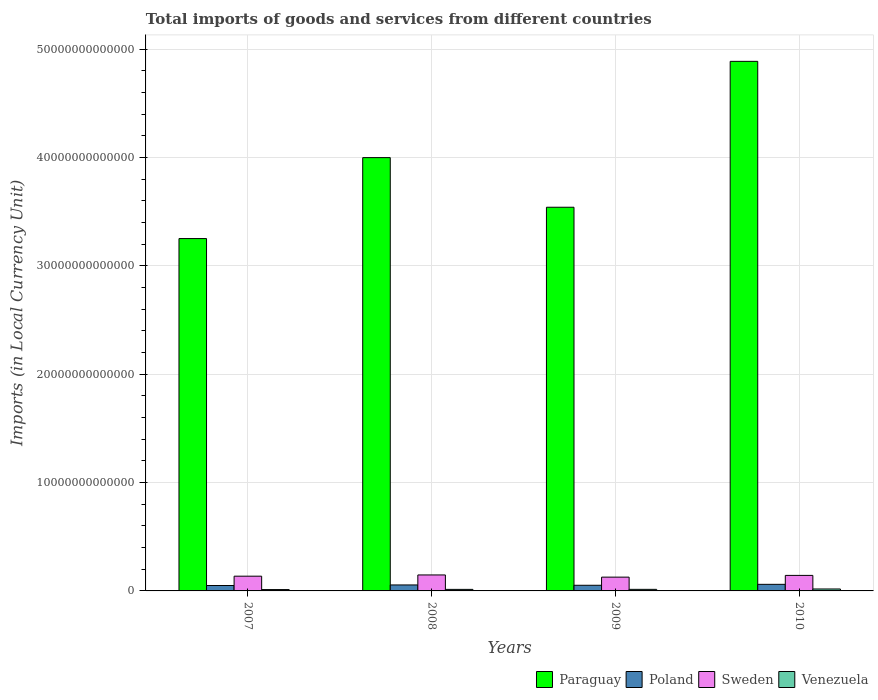How many different coloured bars are there?
Your answer should be compact. 4. Are the number of bars on each tick of the X-axis equal?
Make the answer very short. Yes. How many bars are there on the 1st tick from the right?
Ensure brevity in your answer.  4. What is the label of the 1st group of bars from the left?
Your response must be concise. 2007. In how many cases, is the number of bars for a given year not equal to the number of legend labels?
Give a very brief answer. 0. What is the Amount of goods and services imports in Venezuela in 2007?
Offer a very short reply. 1.24e+11. Across all years, what is the maximum Amount of goods and services imports in Sweden?
Offer a very short reply. 1.48e+12. Across all years, what is the minimum Amount of goods and services imports in Poland?
Make the answer very short. 5.00e+11. What is the total Amount of goods and services imports in Poland in the graph?
Offer a terse response. 2.18e+12. What is the difference between the Amount of goods and services imports in Paraguay in 2007 and that in 2010?
Provide a succinct answer. -1.64e+13. What is the difference between the Amount of goods and services imports in Poland in 2008 and the Amount of goods and services imports in Venezuela in 2010?
Provide a short and direct response. 3.73e+11. What is the average Amount of goods and services imports in Sweden per year?
Ensure brevity in your answer.  1.39e+12. In the year 2008, what is the difference between the Amount of goods and services imports in Venezuela and Amount of goods and services imports in Sweden?
Give a very brief answer. -1.33e+12. What is the ratio of the Amount of goods and services imports in Poland in 2007 to that in 2009?
Provide a short and direct response. 0.96. Is the Amount of goods and services imports in Venezuela in 2007 less than that in 2010?
Make the answer very short. Yes. Is the difference between the Amount of goods and services imports in Venezuela in 2007 and 2009 greater than the difference between the Amount of goods and services imports in Sweden in 2007 and 2009?
Offer a terse response. No. What is the difference between the highest and the second highest Amount of goods and services imports in Poland?
Offer a terse response. 5.61e+1. What is the difference between the highest and the lowest Amount of goods and services imports in Poland?
Keep it short and to the point. 1.08e+11. In how many years, is the Amount of goods and services imports in Venezuela greater than the average Amount of goods and services imports in Venezuela taken over all years?
Provide a succinct answer. 1. Is it the case that in every year, the sum of the Amount of goods and services imports in Venezuela and Amount of goods and services imports in Paraguay is greater than the sum of Amount of goods and services imports in Sweden and Amount of goods and services imports in Poland?
Your answer should be compact. Yes. What does the 1st bar from the left in 2007 represents?
Offer a terse response. Paraguay. How many bars are there?
Your response must be concise. 16. Are all the bars in the graph horizontal?
Your response must be concise. No. How many years are there in the graph?
Your answer should be compact. 4. What is the difference between two consecutive major ticks on the Y-axis?
Provide a short and direct response. 1.00e+13. Are the values on the major ticks of Y-axis written in scientific E-notation?
Your answer should be compact. No. Does the graph contain grids?
Provide a succinct answer. Yes. What is the title of the graph?
Keep it short and to the point. Total imports of goods and services from different countries. What is the label or title of the X-axis?
Offer a very short reply. Years. What is the label or title of the Y-axis?
Your answer should be very brief. Imports (in Local Currency Unit). What is the Imports (in Local Currency Unit) of Paraguay in 2007?
Ensure brevity in your answer.  3.25e+13. What is the Imports (in Local Currency Unit) in Poland in 2007?
Offer a very short reply. 5.00e+11. What is the Imports (in Local Currency Unit) of Sweden in 2007?
Offer a very short reply. 1.36e+12. What is the Imports (in Local Currency Unit) of Venezuela in 2007?
Your response must be concise. 1.24e+11. What is the Imports (in Local Currency Unit) of Paraguay in 2008?
Give a very brief answer. 4.00e+13. What is the Imports (in Local Currency Unit) in Poland in 2008?
Provide a short and direct response. 5.52e+11. What is the Imports (in Local Currency Unit) of Sweden in 2008?
Provide a short and direct response. 1.48e+12. What is the Imports (in Local Currency Unit) of Venezuela in 2008?
Offer a very short reply. 1.42e+11. What is the Imports (in Local Currency Unit) of Paraguay in 2009?
Ensure brevity in your answer.  3.54e+13. What is the Imports (in Local Currency Unit) in Poland in 2009?
Provide a short and direct response. 5.22e+11. What is the Imports (in Local Currency Unit) of Sweden in 2009?
Offer a terse response. 1.27e+12. What is the Imports (in Local Currency Unit) of Venezuela in 2009?
Provide a short and direct response. 1.45e+11. What is the Imports (in Local Currency Unit) in Paraguay in 2010?
Give a very brief answer. 4.89e+13. What is the Imports (in Local Currency Unit) in Poland in 2010?
Offer a very short reply. 6.08e+11. What is the Imports (in Local Currency Unit) of Sweden in 2010?
Provide a short and direct response. 1.43e+12. What is the Imports (in Local Currency Unit) of Venezuela in 2010?
Your answer should be very brief. 1.79e+11. Across all years, what is the maximum Imports (in Local Currency Unit) of Paraguay?
Ensure brevity in your answer.  4.89e+13. Across all years, what is the maximum Imports (in Local Currency Unit) in Poland?
Offer a terse response. 6.08e+11. Across all years, what is the maximum Imports (in Local Currency Unit) of Sweden?
Keep it short and to the point. 1.48e+12. Across all years, what is the maximum Imports (in Local Currency Unit) of Venezuela?
Offer a very short reply. 1.79e+11. Across all years, what is the minimum Imports (in Local Currency Unit) in Paraguay?
Offer a very short reply. 3.25e+13. Across all years, what is the minimum Imports (in Local Currency Unit) in Poland?
Offer a very short reply. 5.00e+11. Across all years, what is the minimum Imports (in Local Currency Unit) in Sweden?
Keep it short and to the point. 1.27e+12. Across all years, what is the minimum Imports (in Local Currency Unit) of Venezuela?
Give a very brief answer. 1.24e+11. What is the total Imports (in Local Currency Unit) of Paraguay in the graph?
Offer a very short reply. 1.57e+14. What is the total Imports (in Local Currency Unit) in Poland in the graph?
Ensure brevity in your answer.  2.18e+12. What is the total Imports (in Local Currency Unit) in Sweden in the graph?
Your answer should be compact. 5.54e+12. What is the total Imports (in Local Currency Unit) in Venezuela in the graph?
Your answer should be very brief. 5.90e+11. What is the difference between the Imports (in Local Currency Unit) of Paraguay in 2007 and that in 2008?
Your response must be concise. -7.47e+12. What is the difference between the Imports (in Local Currency Unit) in Poland in 2007 and that in 2008?
Make the answer very short. -5.17e+1. What is the difference between the Imports (in Local Currency Unit) in Sweden in 2007 and that in 2008?
Make the answer very short. -1.14e+11. What is the difference between the Imports (in Local Currency Unit) of Venezuela in 2007 and that in 2008?
Offer a very short reply. -1.84e+1. What is the difference between the Imports (in Local Currency Unit) in Paraguay in 2007 and that in 2009?
Make the answer very short. -2.89e+12. What is the difference between the Imports (in Local Currency Unit) of Poland in 2007 and that in 2009?
Provide a short and direct response. -2.21e+1. What is the difference between the Imports (in Local Currency Unit) of Sweden in 2007 and that in 2009?
Give a very brief answer. 8.87e+1. What is the difference between the Imports (in Local Currency Unit) in Venezuela in 2007 and that in 2009?
Provide a short and direct response. -2.06e+1. What is the difference between the Imports (in Local Currency Unit) in Paraguay in 2007 and that in 2010?
Your response must be concise. -1.64e+13. What is the difference between the Imports (in Local Currency Unit) in Poland in 2007 and that in 2010?
Your answer should be compact. -1.08e+11. What is the difference between the Imports (in Local Currency Unit) of Sweden in 2007 and that in 2010?
Give a very brief answer. -7.22e+1. What is the difference between the Imports (in Local Currency Unit) of Venezuela in 2007 and that in 2010?
Your answer should be compact. -5.50e+1. What is the difference between the Imports (in Local Currency Unit) of Paraguay in 2008 and that in 2009?
Provide a succinct answer. 4.58e+12. What is the difference between the Imports (in Local Currency Unit) in Poland in 2008 and that in 2009?
Offer a very short reply. 2.97e+1. What is the difference between the Imports (in Local Currency Unit) of Sweden in 2008 and that in 2009?
Provide a short and direct response. 2.03e+11. What is the difference between the Imports (in Local Currency Unit) in Venezuela in 2008 and that in 2009?
Ensure brevity in your answer.  -2.29e+09. What is the difference between the Imports (in Local Currency Unit) in Paraguay in 2008 and that in 2010?
Ensure brevity in your answer.  -8.89e+12. What is the difference between the Imports (in Local Currency Unit) of Poland in 2008 and that in 2010?
Make the answer very short. -5.61e+1. What is the difference between the Imports (in Local Currency Unit) of Sweden in 2008 and that in 2010?
Your answer should be compact. 4.19e+1. What is the difference between the Imports (in Local Currency Unit) of Venezuela in 2008 and that in 2010?
Offer a terse response. -3.67e+1. What is the difference between the Imports (in Local Currency Unit) in Paraguay in 2009 and that in 2010?
Provide a succinct answer. -1.35e+13. What is the difference between the Imports (in Local Currency Unit) of Poland in 2009 and that in 2010?
Ensure brevity in your answer.  -8.58e+1. What is the difference between the Imports (in Local Currency Unit) of Sweden in 2009 and that in 2010?
Offer a very short reply. -1.61e+11. What is the difference between the Imports (in Local Currency Unit) of Venezuela in 2009 and that in 2010?
Your answer should be compact. -3.44e+1. What is the difference between the Imports (in Local Currency Unit) in Paraguay in 2007 and the Imports (in Local Currency Unit) in Poland in 2008?
Give a very brief answer. 3.20e+13. What is the difference between the Imports (in Local Currency Unit) in Paraguay in 2007 and the Imports (in Local Currency Unit) in Sweden in 2008?
Offer a very short reply. 3.10e+13. What is the difference between the Imports (in Local Currency Unit) in Paraguay in 2007 and the Imports (in Local Currency Unit) in Venezuela in 2008?
Make the answer very short. 3.24e+13. What is the difference between the Imports (in Local Currency Unit) in Poland in 2007 and the Imports (in Local Currency Unit) in Sweden in 2008?
Ensure brevity in your answer.  -9.75e+11. What is the difference between the Imports (in Local Currency Unit) of Poland in 2007 and the Imports (in Local Currency Unit) of Venezuela in 2008?
Offer a terse response. 3.58e+11. What is the difference between the Imports (in Local Currency Unit) in Sweden in 2007 and the Imports (in Local Currency Unit) in Venezuela in 2008?
Offer a very short reply. 1.22e+12. What is the difference between the Imports (in Local Currency Unit) in Paraguay in 2007 and the Imports (in Local Currency Unit) in Poland in 2009?
Give a very brief answer. 3.20e+13. What is the difference between the Imports (in Local Currency Unit) of Paraguay in 2007 and the Imports (in Local Currency Unit) of Sweden in 2009?
Keep it short and to the point. 3.12e+13. What is the difference between the Imports (in Local Currency Unit) in Paraguay in 2007 and the Imports (in Local Currency Unit) in Venezuela in 2009?
Offer a very short reply. 3.24e+13. What is the difference between the Imports (in Local Currency Unit) of Poland in 2007 and the Imports (in Local Currency Unit) of Sweden in 2009?
Ensure brevity in your answer.  -7.72e+11. What is the difference between the Imports (in Local Currency Unit) in Poland in 2007 and the Imports (in Local Currency Unit) in Venezuela in 2009?
Offer a very short reply. 3.55e+11. What is the difference between the Imports (in Local Currency Unit) in Sweden in 2007 and the Imports (in Local Currency Unit) in Venezuela in 2009?
Offer a very short reply. 1.22e+12. What is the difference between the Imports (in Local Currency Unit) in Paraguay in 2007 and the Imports (in Local Currency Unit) in Poland in 2010?
Keep it short and to the point. 3.19e+13. What is the difference between the Imports (in Local Currency Unit) in Paraguay in 2007 and the Imports (in Local Currency Unit) in Sweden in 2010?
Make the answer very short. 3.11e+13. What is the difference between the Imports (in Local Currency Unit) in Paraguay in 2007 and the Imports (in Local Currency Unit) in Venezuela in 2010?
Offer a terse response. 3.23e+13. What is the difference between the Imports (in Local Currency Unit) in Poland in 2007 and the Imports (in Local Currency Unit) in Sweden in 2010?
Your answer should be very brief. -9.33e+11. What is the difference between the Imports (in Local Currency Unit) of Poland in 2007 and the Imports (in Local Currency Unit) of Venezuela in 2010?
Your answer should be very brief. 3.21e+11. What is the difference between the Imports (in Local Currency Unit) in Sweden in 2007 and the Imports (in Local Currency Unit) in Venezuela in 2010?
Ensure brevity in your answer.  1.18e+12. What is the difference between the Imports (in Local Currency Unit) in Paraguay in 2008 and the Imports (in Local Currency Unit) in Poland in 2009?
Keep it short and to the point. 3.95e+13. What is the difference between the Imports (in Local Currency Unit) in Paraguay in 2008 and the Imports (in Local Currency Unit) in Sweden in 2009?
Provide a succinct answer. 3.87e+13. What is the difference between the Imports (in Local Currency Unit) in Paraguay in 2008 and the Imports (in Local Currency Unit) in Venezuela in 2009?
Offer a terse response. 3.98e+13. What is the difference between the Imports (in Local Currency Unit) in Poland in 2008 and the Imports (in Local Currency Unit) in Sweden in 2009?
Ensure brevity in your answer.  -7.21e+11. What is the difference between the Imports (in Local Currency Unit) of Poland in 2008 and the Imports (in Local Currency Unit) of Venezuela in 2009?
Provide a succinct answer. 4.07e+11. What is the difference between the Imports (in Local Currency Unit) in Sweden in 2008 and the Imports (in Local Currency Unit) in Venezuela in 2009?
Offer a terse response. 1.33e+12. What is the difference between the Imports (in Local Currency Unit) of Paraguay in 2008 and the Imports (in Local Currency Unit) of Poland in 2010?
Give a very brief answer. 3.94e+13. What is the difference between the Imports (in Local Currency Unit) of Paraguay in 2008 and the Imports (in Local Currency Unit) of Sweden in 2010?
Keep it short and to the point. 3.86e+13. What is the difference between the Imports (in Local Currency Unit) of Paraguay in 2008 and the Imports (in Local Currency Unit) of Venezuela in 2010?
Your response must be concise. 3.98e+13. What is the difference between the Imports (in Local Currency Unit) of Poland in 2008 and the Imports (in Local Currency Unit) of Sweden in 2010?
Keep it short and to the point. -8.82e+11. What is the difference between the Imports (in Local Currency Unit) in Poland in 2008 and the Imports (in Local Currency Unit) in Venezuela in 2010?
Make the answer very short. 3.73e+11. What is the difference between the Imports (in Local Currency Unit) in Sweden in 2008 and the Imports (in Local Currency Unit) in Venezuela in 2010?
Offer a very short reply. 1.30e+12. What is the difference between the Imports (in Local Currency Unit) of Paraguay in 2009 and the Imports (in Local Currency Unit) of Poland in 2010?
Your answer should be very brief. 3.48e+13. What is the difference between the Imports (in Local Currency Unit) in Paraguay in 2009 and the Imports (in Local Currency Unit) in Sweden in 2010?
Provide a short and direct response. 3.40e+13. What is the difference between the Imports (in Local Currency Unit) in Paraguay in 2009 and the Imports (in Local Currency Unit) in Venezuela in 2010?
Provide a succinct answer. 3.52e+13. What is the difference between the Imports (in Local Currency Unit) of Poland in 2009 and the Imports (in Local Currency Unit) of Sweden in 2010?
Provide a short and direct response. -9.11e+11. What is the difference between the Imports (in Local Currency Unit) of Poland in 2009 and the Imports (in Local Currency Unit) of Venezuela in 2010?
Your answer should be very brief. 3.43e+11. What is the difference between the Imports (in Local Currency Unit) of Sweden in 2009 and the Imports (in Local Currency Unit) of Venezuela in 2010?
Your answer should be compact. 1.09e+12. What is the average Imports (in Local Currency Unit) of Paraguay per year?
Your response must be concise. 3.92e+13. What is the average Imports (in Local Currency Unit) of Poland per year?
Offer a very short reply. 5.45e+11. What is the average Imports (in Local Currency Unit) of Sweden per year?
Give a very brief answer. 1.39e+12. What is the average Imports (in Local Currency Unit) of Venezuela per year?
Provide a succinct answer. 1.47e+11. In the year 2007, what is the difference between the Imports (in Local Currency Unit) of Paraguay and Imports (in Local Currency Unit) of Poland?
Your answer should be very brief. 3.20e+13. In the year 2007, what is the difference between the Imports (in Local Currency Unit) in Paraguay and Imports (in Local Currency Unit) in Sweden?
Offer a very short reply. 3.12e+13. In the year 2007, what is the difference between the Imports (in Local Currency Unit) in Paraguay and Imports (in Local Currency Unit) in Venezuela?
Offer a very short reply. 3.24e+13. In the year 2007, what is the difference between the Imports (in Local Currency Unit) in Poland and Imports (in Local Currency Unit) in Sweden?
Ensure brevity in your answer.  -8.61e+11. In the year 2007, what is the difference between the Imports (in Local Currency Unit) in Poland and Imports (in Local Currency Unit) in Venezuela?
Your answer should be very brief. 3.76e+11. In the year 2007, what is the difference between the Imports (in Local Currency Unit) of Sweden and Imports (in Local Currency Unit) of Venezuela?
Your answer should be very brief. 1.24e+12. In the year 2008, what is the difference between the Imports (in Local Currency Unit) in Paraguay and Imports (in Local Currency Unit) in Poland?
Your answer should be compact. 3.94e+13. In the year 2008, what is the difference between the Imports (in Local Currency Unit) of Paraguay and Imports (in Local Currency Unit) of Sweden?
Your response must be concise. 3.85e+13. In the year 2008, what is the difference between the Imports (in Local Currency Unit) of Paraguay and Imports (in Local Currency Unit) of Venezuela?
Ensure brevity in your answer.  3.99e+13. In the year 2008, what is the difference between the Imports (in Local Currency Unit) in Poland and Imports (in Local Currency Unit) in Sweden?
Offer a very short reply. -9.23e+11. In the year 2008, what is the difference between the Imports (in Local Currency Unit) in Poland and Imports (in Local Currency Unit) in Venezuela?
Give a very brief answer. 4.09e+11. In the year 2008, what is the difference between the Imports (in Local Currency Unit) in Sweden and Imports (in Local Currency Unit) in Venezuela?
Make the answer very short. 1.33e+12. In the year 2009, what is the difference between the Imports (in Local Currency Unit) in Paraguay and Imports (in Local Currency Unit) in Poland?
Your answer should be very brief. 3.49e+13. In the year 2009, what is the difference between the Imports (in Local Currency Unit) of Paraguay and Imports (in Local Currency Unit) of Sweden?
Your response must be concise. 3.41e+13. In the year 2009, what is the difference between the Imports (in Local Currency Unit) of Paraguay and Imports (in Local Currency Unit) of Venezuela?
Make the answer very short. 3.53e+13. In the year 2009, what is the difference between the Imports (in Local Currency Unit) in Poland and Imports (in Local Currency Unit) in Sweden?
Offer a terse response. -7.50e+11. In the year 2009, what is the difference between the Imports (in Local Currency Unit) in Poland and Imports (in Local Currency Unit) in Venezuela?
Keep it short and to the point. 3.77e+11. In the year 2009, what is the difference between the Imports (in Local Currency Unit) of Sweden and Imports (in Local Currency Unit) of Venezuela?
Make the answer very short. 1.13e+12. In the year 2010, what is the difference between the Imports (in Local Currency Unit) in Paraguay and Imports (in Local Currency Unit) in Poland?
Provide a short and direct response. 4.83e+13. In the year 2010, what is the difference between the Imports (in Local Currency Unit) in Paraguay and Imports (in Local Currency Unit) in Sweden?
Make the answer very short. 4.74e+13. In the year 2010, what is the difference between the Imports (in Local Currency Unit) in Paraguay and Imports (in Local Currency Unit) in Venezuela?
Make the answer very short. 4.87e+13. In the year 2010, what is the difference between the Imports (in Local Currency Unit) of Poland and Imports (in Local Currency Unit) of Sweden?
Ensure brevity in your answer.  -8.25e+11. In the year 2010, what is the difference between the Imports (in Local Currency Unit) of Poland and Imports (in Local Currency Unit) of Venezuela?
Provide a short and direct response. 4.29e+11. In the year 2010, what is the difference between the Imports (in Local Currency Unit) of Sweden and Imports (in Local Currency Unit) of Venezuela?
Provide a succinct answer. 1.25e+12. What is the ratio of the Imports (in Local Currency Unit) of Paraguay in 2007 to that in 2008?
Your answer should be very brief. 0.81. What is the ratio of the Imports (in Local Currency Unit) of Poland in 2007 to that in 2008?
Your answer should be compact. 0.91. What is the ratio of the Imports (in Local Currency Unit) in Sweden in 2007 to that in 2008?
Make the answer very short. 0.92. What is the ratio of the Imports (in Local Currency Unit) of Venezuela in 2007 to that in 2008?
Ensure brevity in your answer.  0.87. What is the ratio of the Imports (in Local Currency Unit) of Paraguay in 2007 to that in 2009?
Offer a terse response. 0.92. What is the ratio of the Imports (in Local Currency Unit) of Poland in 2007 to that in 2009?
Give a very brief answer. 0.96. What is the ratio of the Imports (in Local Currency Unit) of Sweden in 2007 to that in 2009?
Give a very brief answer. 1.07. What is the ratio of the Imports (in Local Currency Unit) of Venezuela in 2007 to that in 2009?
Give a very brief answer. 0.86. What is the ratio of the Imports (in Local Currency Unit) of Paraguay in 2007 to that in 2010?
Make the answer very short. 0.67. What is the ratio of the Imports (in Local Currency Unit) of Poland in 2007 to that in 2010?
Keep it short and to the point. 0.82. What is the ratio of the Imports (in Local Currency Unit) in Sweden in 2007 to that in 2010?
Offer a terse response. 0.95. What is the ratio of the Imports (in Local Currency Unit) of Venezuela in 2007 to that in 2010?
Your response must be concise. 0.69. What is the ratio of the Imports (in Local Currency Unit) of Paraguay in 2008 to that in 2009?
Provide a short and direct response. 1.13. What is the ratio of the Imports (in Local Currency Unit) of Poland in 2008 to that in 2009?
Your answer should be very brief. 1.06. What is the ratio of the Imports (in Local Currency Unit) of Sweden in 2008 to that in 2009?
Give a very brief answer. 1.16. What is the ratio of the Imports (in Local Currency Unit) of Venezuela in 2008 to that in 2009?
Make the answer very short. 0.98. What is the ratio of the Imports (in Local Currency Unit) of Paraguay in 2008 to that in 2010?
Your answer should be compact. 0.82. What is the ratio of the Imports (in Local Currency Unit) of Poland in 2008 to that in 2010?
Provide a short and direct response. 0.91. What is the ratio of the Imports (in Local Currency Unit) of Sweden in 2008 to that in 2010?
Offer a very short reply. 1.03. What is the ratio of the Imports (in Local Currency Unit) in Venezuela in 2008 to that in 2010?
Your response must be concise. 0.8. What is the ratio of the Imports (in Local Currency Unit) of Paraguay in 2009 to that in 2010?
Provide a succinct answer. 0.72. What is the ratio of the Imports (in Local Currency Unit) in Poland in 2009 to that in 2010?
Provide a short and direct response. 0.86. What is the ratio of the Imports (in Local Currency Unit) in Sweden in 2009 to that in 2010?
Your answer should be very brief. 0.89. What is the ratio of the Imports (in Local Currency Unit) in Venezuela in 2009 to that in 2010?
Offer a very short reply. 0.81. What is the difference between the highest and the second highest Imports (in Local Currency Unit) of Paraguay?
Offer a very short reply. 8.89e+12. What is the difference between the highest and the second highest Imports (in Local Currency Unit) of Poland?
Make the answer very short. 5.61e+1. What is the difference between the highest and the second highest Imports (in Local Currency Unit) in Sweden?
Keep it short and to the point. 4.19e+1. What is the difference between the highest and the second highest Imports (in Local Currency Unit) of Venezuela?
Keep it short and to the point. 3.44e+1. What is the difference between the highest and the lowest Imports (in Local Currency Unit) of Paraguay?
Provide a short and direct response. 1.64e+13. What is the difference between the highest and the lowest Imports (in Local Currency Unit) in Poland?
Your answer should be compact. 1.08e+11. What is the difference between the highest and the lowest Imports (in Local Currency Unit) in Sweden?
Make the answer very short. 2.03e+11. What is the difference between the highest and the lowest Imports (in Local Currency Unit) in Venezuela?
Make the answer very short. 5.50e+1. 